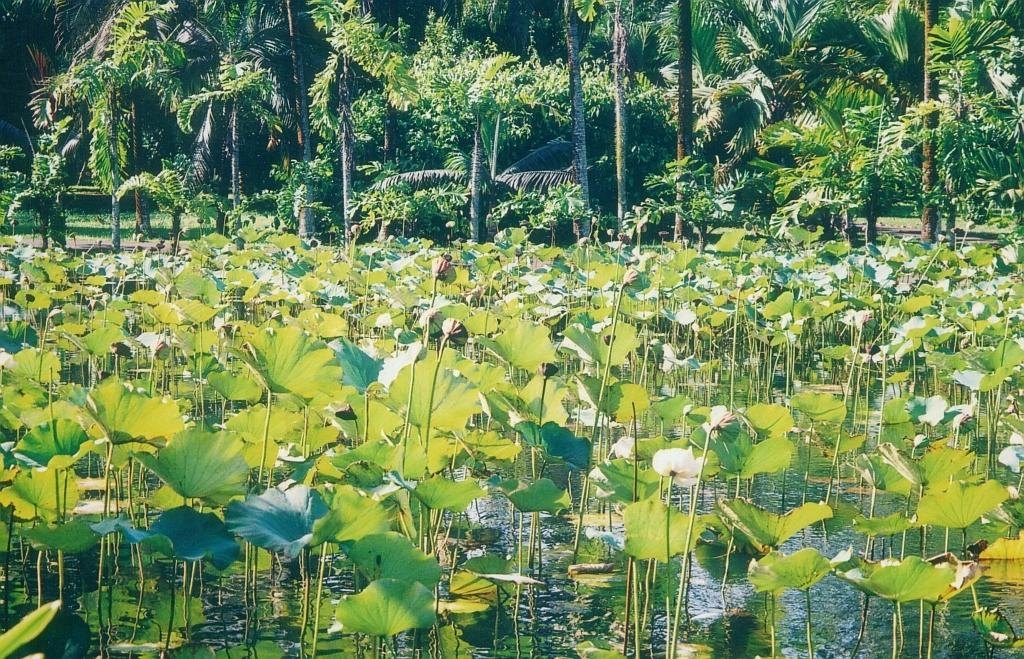What type of plants can be seen in the water in the image? There are plants in the water in the image. What other types of plants can be seen in the image? There are flowers and trees in the image. What type of vegetation is present on the ground in the image? There is grass in the image. How many oranges are hanging from the trees in the image? There are no oranges present in the image; it features plants in the water, flowers, trees, and grass. 